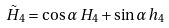<formula> <loc_0><loc_0><loc_500><loc_500>\tilde { H } _ { 4 } = \cos \alpha \, H _ { 4 } + \sin \alpha \, h _ { 4 }</formula> 